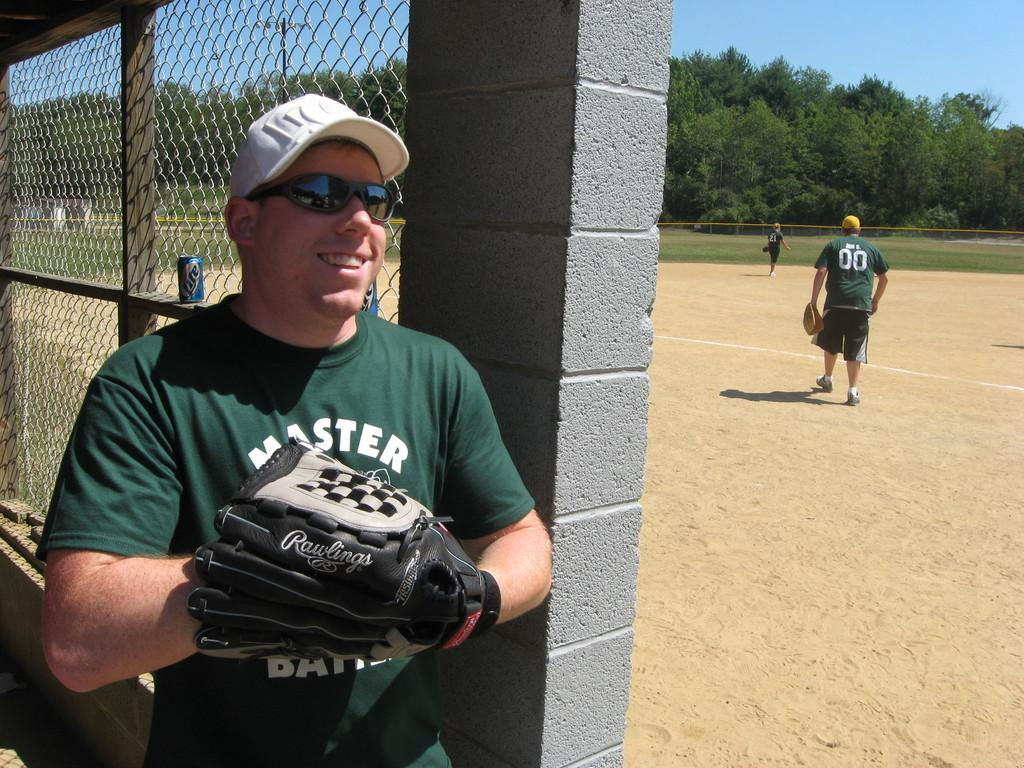<image>
Describe the image concisely. Player 00 is out on the dirt ball field. 